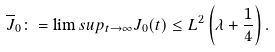<formula> <loc_0><loc_0><loc_500><loc_500>\overline { J } _ { 0 } \colon = \lim s u p _ { t \to \infty } J _ { 0 } ( t ) \leq L ^ { 2 } \left ( \lambda + \frac { 1 } { 4 } \right ) .</formula> 